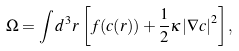<formula> <loc_0><loc_0><loc_500><loc_500>\Omega = \int d ^ { 3 } r \, \left [ f ( c ( r ) ) + \frac { 1 } { 2 } \kappa \left | \nabla c \right | ^ { 2 } \right ] ,</formula> 